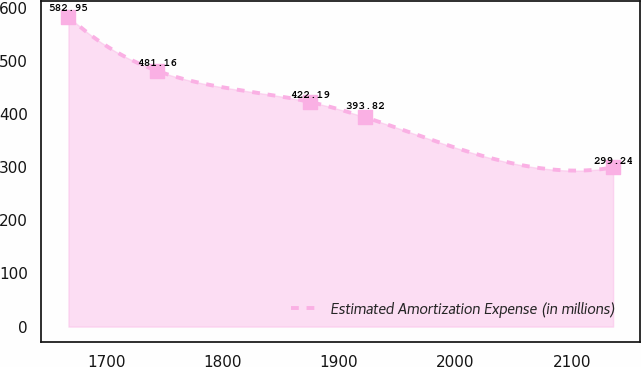<chart> <loc_0><loc_0><loc_500><loc_500><line_chart><ecel><fcel>Estimated Amortization Expense (in millions)<nl><fcel>1667.28<fcel>582.95<nl><fcel>1743.25<fcel>481.16<nl><fcel>1875.34<fcel>422.19<nl><fcel>1922.18<fcel>393.82<nl><fcel>2135.65<fcel>299.24<nl></chart> 